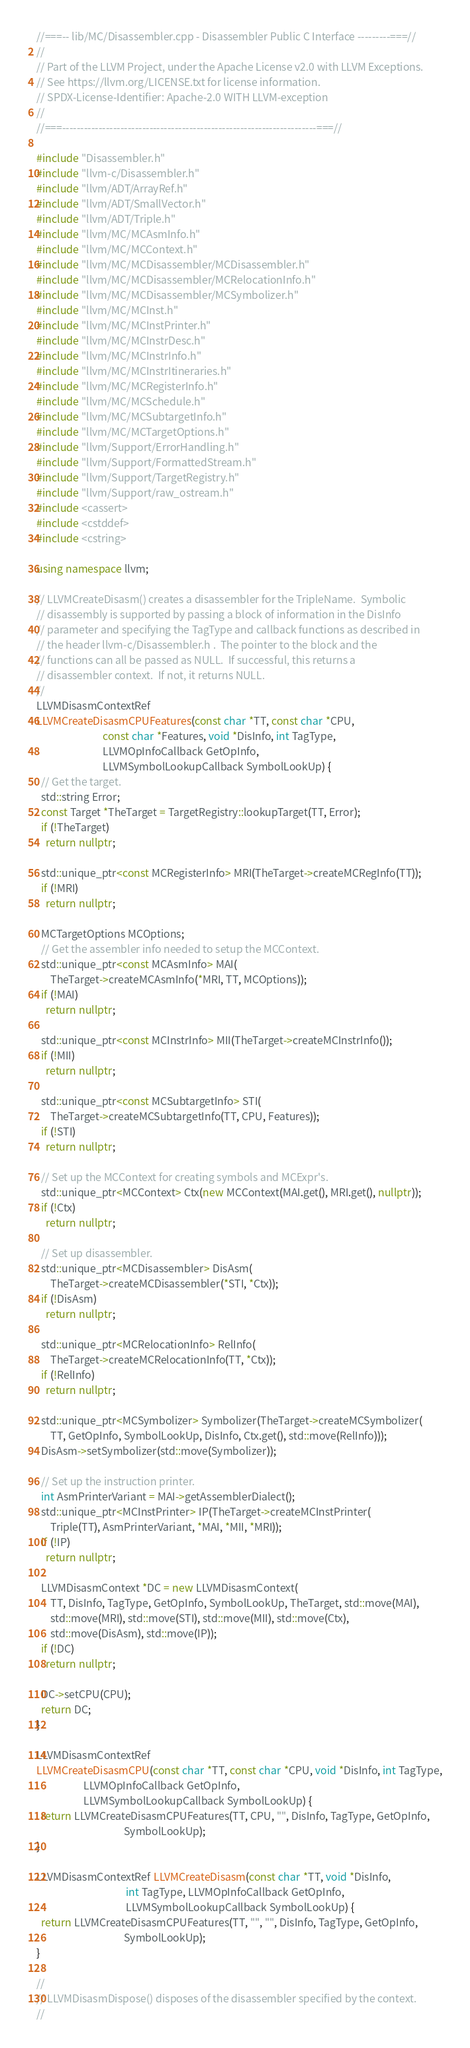<code> <loc_0><loc_0><loc_500><loc_500><_C++_>//===-- lib/MC/Disassembler.cpp - Disassembler Public C Interface ---------===//
//
// Part of the LLVM Project, under the Apache License v2.0 with LLVM Exceptions.
// See https://llvm.org/LICENSE.txt for license information.
// SPDX-License-Identifier: Apache-2.0 WITH LLVM-exception
//
//===----------------------------------------------------------------------===//

#include "Disassembler.h"
#include "llvm-c/Disassembler.h"
#include "llvm/ADT/ArrayRef.h"
#include "llvm/ADT/SmallVector.h"
#include "llvm/ADT/Triple.h"
#include "llvm/MC/MCAsmInfo.h"
#include "llvm/MC/MCContext.h"
#include "llvm/MC/MCDisassembler/MCDisassembler.h"
#include "llvm/MC/MCDisassembler/MCRelocationInfo.h"
#include "llvm/MC/MCDisassembler/MCSymbolizer.h"
#include "llvm/MC/MCInst.h"
#include "llvm/MC/MCInstPrinter.h"
#include "llvm/MC/MCInstrDesc.h"
#include "llvm/MC/MCInstrInfo.h"
#include "llvm/MC/MCInstrItineraries.h"
#include "llvm/MC/MCRegisterInfo.h"
#include "llvm/MC/MCSchedule.h"
#include "llvm/MC/MCSubtargetInfo.h"
#include "llvm/MC/MCTargetOptions.h"
#include "llvm/Support/ErrorHandling.h"
#include "llvm/Support/FormattedStream.h"
#include "llvm/Support/TargetRegistry.h"
#include "llvm/Support/raw_ostream.h"
#include <cassert>
#include <cstddef>
#include <cstring>

using namespace llvm;

// LLVMCreateDisasm() creates a disassembler for the TripleName.  Symbolic
// disassembly is supported by passing a block of information in the DisInfo
// parameter and specifying the TagType and callback functions as described in
// the header llvm-c/Disassembler.h .  The pointer to the block and the
// functions can all be passed as NULL.  If successful, this returns a
// disassembler context.  If not, it returns NULL.
//
LLVMDisasmContextRef
LLVMCreateDisasmCPUFeatures(const char *TT, const char *CPU,
                            const char *Features, void *DisInfo, int TagType,
                            LLVMOpInfoCallback GetOpInfo,
                            LLVMSymbolLookupCallback SymbolLookUp) {
  // Get the target.
  std::string Error;
  const Target *TheTarget = TargetRegistry::lookupTarget(TT, Error);
  if (!TheTarget)
    return nullptr;

  std::unique_ptr<const MCRegisterInfo> MRI(TheTarget->createMCRegInfo(TT));
  if (!MRI)
    return nullptr;

  MCTargetOptions MCOptions;
  // Get the assembler info needed to setup the MCContext.
  std::unique_ptr<const MCAsmInfo> MAI(
      TheTarget->createMCAsmInfo(*MRI, TT, MCOptions));
  if (!MAI)
    return nullptr;

  std::unique_ptr<const MCInstrInfo> MII(TheTarget->createMCInstrInfo());
  if (!MII)
    return nullptr;

  std::unique_ptr<const MCSubtargetInfo> STI(
      TheTarget->createMCSubtargetInfo(TT, CPU, Features));
  if (!STI)
    return nullptr;

  // Set up the MCContext for creating symbols and MCExpr's.
  std::unique_ptr<MCContext> Ctx(new MCContext(MAI.get(), MRI.get(), nullptr));
  if (!Ctx)
    return nullptr;

  // Set up disassembler.
  std::unique_ptr<MCDisassembler> DisAsm(
      TheTarget->createMCDisassembler(*STI, *Ctx));
  if (!DisAsm)
    return nullptr;

  std::unique_ptr<MCRelocationInfo> RelInfo(
      TheTarget->createMCRelocationInfo(TT, *Ctx));
  if (!RelInfo)
    return nullptr;

  std::unique_ptr<MCSymbolizer> Symbolizer(TheTarget->createMCSymbolizer(
      TT, GetOpInfo, SymbolLookUp, DisInfo, Ctx.get(), std::move(RelInfo)));
  DisAsm->setSymbolizer(std::move(Symbolizer));

  // Set up the instruction printer.
  int AsmPrinterVariant = MAI->getAssemblerDialect();
  std::unique_ptr<MCInstPrinter> IP(TheTarget->createMCInstPrinter(
      Triple(TT), AsmPrinterVariant, *MAI, *MII, *MRI));
  if (!IP)
    return nullptr;

  LLVMDisasmContext *DC = new LLVMDisasmContext(
      TT, DisInfo, TagType, GetOpInfo, SymbolLookUp, TheTarget, std::move(MAI),
      std::move(MRI), std::move(STI), std::move(MII), std::move(Ctx),
      std::move(DisAsm), std::move(IP));
  if (!DC)
    return nullptr;

  DC->setCPU(CPU);
  return DC;
}

LLVMDisasmContextRef
LLVMCreateDisasmCPU(const char *TT, const char *CPU, void *DisInfo, int TagType,
                    LLVMOpInfoCallback GetOpInfo,
                    LLVMSymbolLookupCallback SymbolLookUp) {
  return LLVMCreateDisasmCPUFeatures(TT, CPU, "", DisInfo, TagType, GetOpInfo,
                                     SymbolLookUp);
}

LLVMDisasmContextRef LLVMCreateDisasm(const char *TT, void *DisInfo,
                                      int TagType, LLVMOpInfoCallback GetOpInfo,
                                      LLVMSymbolLookupCallback SymbolLookUp) {
  return LLVMCreateDisasmCPUFeatures(TT, "", "", DisInfo, TagType, GetOpInfo,
                                     SymbolLookUp);
}

//
// LLVMDisasmDispose() disposes of the disassembler specified by the context.
//</code> 